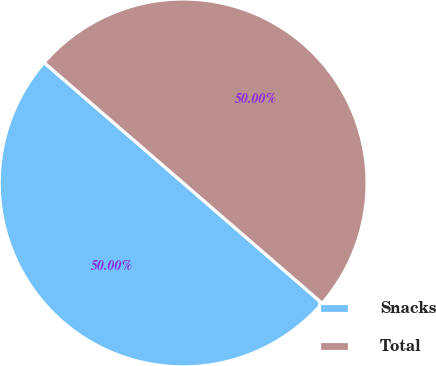Convert chart. <chart><loc_0><loc_0><loc_500><loc_500><pie_chart><fcel>Snacks<fcel>Total<nl><fcel>50.0%<fcel>50.0%<nl></chart> 